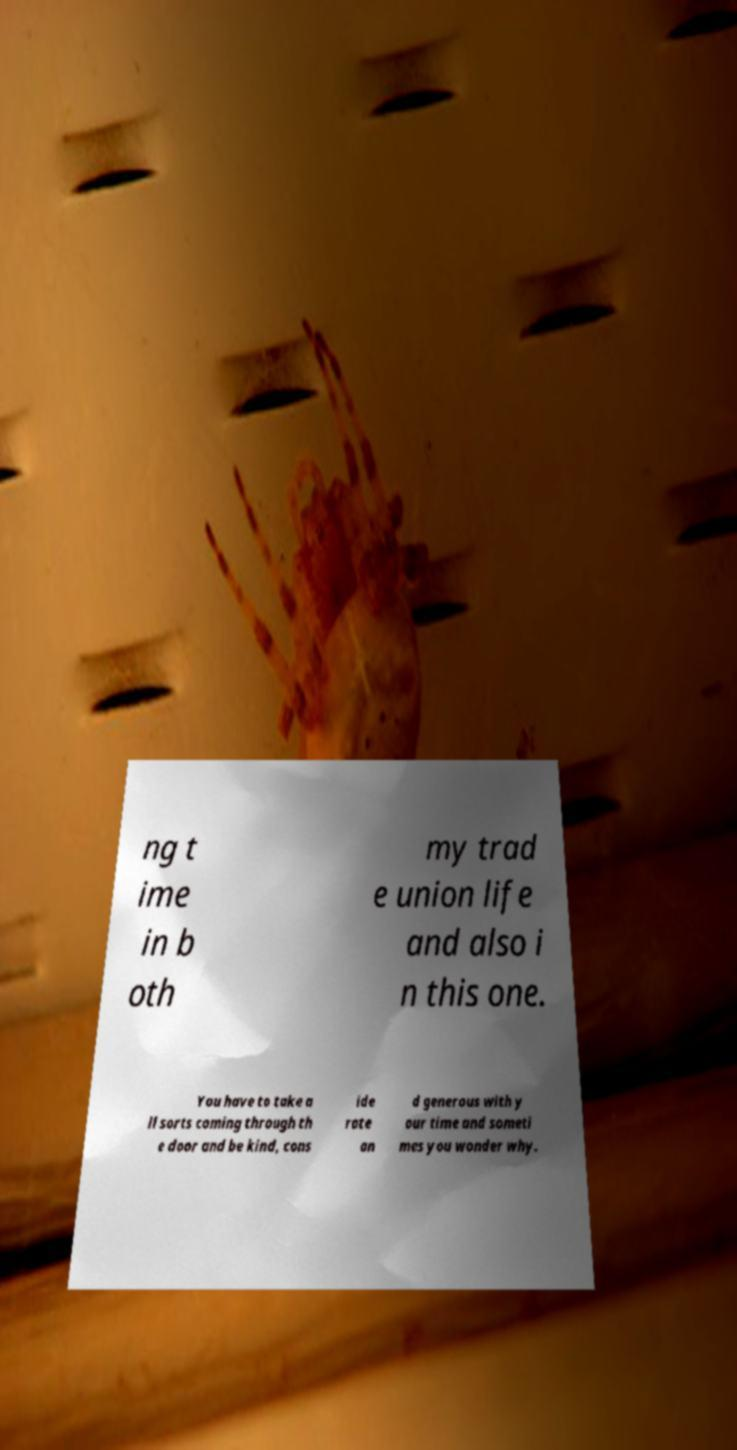Could you assist in decoding the text presented in this image and type it out clearly? ng t ime in b oth my trad e union life and also i n this one. You have to take a ll sorts coming through th e door and be kind, cons ide rate an d generous with y our time and someti mes you wonder why. 